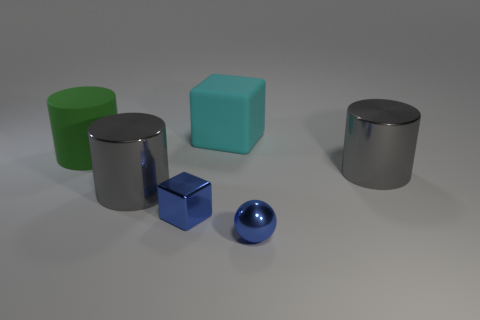Subtract all cyan cubes. How many gray cylinders are left? 2 Subtract all matte cylinders. How many cylinders are left? 2 Add 4 tiny green rubber blocks. How many objects exist? 10 Subtract all balls. How many objects are left? 5 Add 1 tiny rubber spheres. How many tiny rubber spheres exist? 1 Subtract 0 green cubes. How many objects are left? 6 Subtract all big cylinders. Subtract all green matte cylinders. How many objects are left? 2 Add 4 matte cylinders. How many matte cylinders are left? 5 